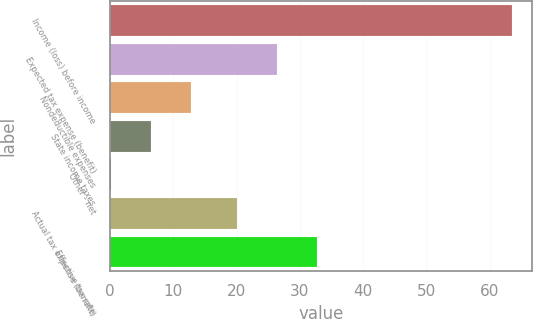Convert chart to OTSL. <chart><loc_0><loc_0><loc_500><loc_500><bar_chart><fcel>Income (loss) before income<fcel>Expected tax expense (benefit)<fcel>Nondeductible expenses<fcel>State income taxes<fcel>Other - net<fcel>Actual tax expense (benefit)<fcel>Effective tax rate<nl><fcel>63.5<fcel>26.44<fcel>12.78<fcel>6.44<fcel>0.1<fcel>20.1<fcel>32.78<nl></chart> 